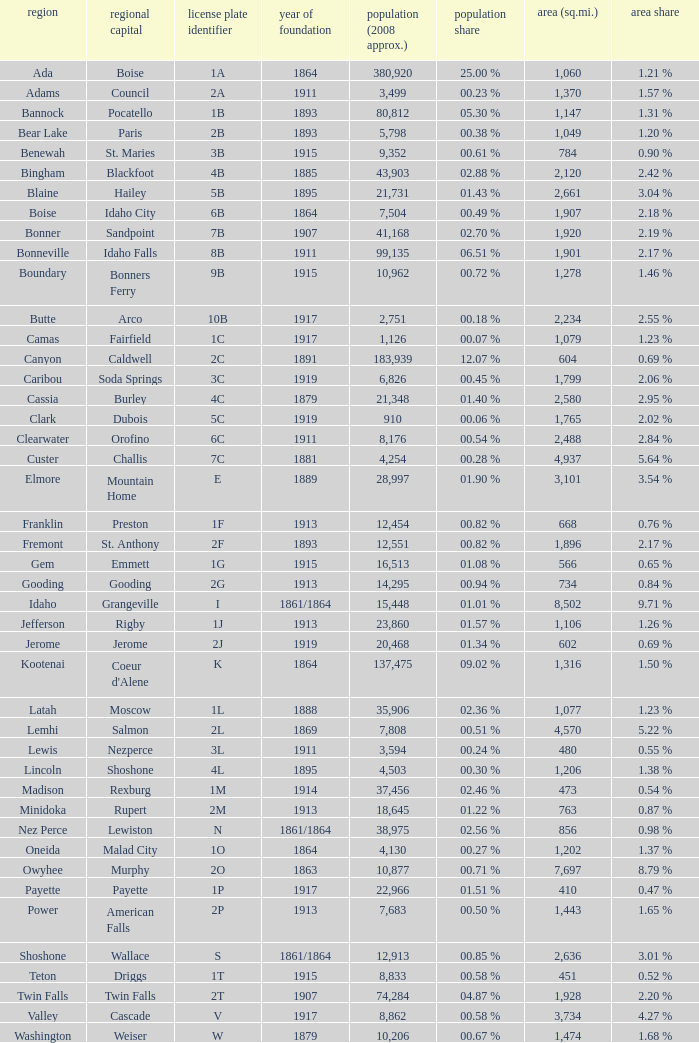What is the country seat for the license plate code 5c? Dubois. Would you mind parsing the complete table? {'header': ['region', 'regional capital', 'license plate identifier', 'year of foundation', 'population (2008 approx.)', 'population share', 'area (sq.mi.)', 'area share'], 'rows': [['Ada', 'Boise', '1A', '1864', '380,920', '25.00 %', '1,060', '1.21 %'], ['Adams', 'Council', '2A', '1911', '3,499', '00.23 %', '1,370', '1.57 %'], ['Bannock', 'Pocatello', '1B', '1893', '80,812', '05.30 %', '1,147', '1.31 %'], ['Bear Lake', 'Paris', '2B', '1893', '5,798', '00.38 %', '1,049', '1.20 %'], ['Benewah', 'St. Maries', '3B', '1915', '9,352', '00.61 %', '784', '0.90 %'], ['Bingham', 'Blackfoot', '4B', '1885', '43,903', '02.88 %', '2,120', '2.42 %'], ['Blaine', 'Hailey', '5B', '1895', '21,731', '01.43 %', '2,661', '3.04 %'], ['Boise', 'Idaho City', '6B', '1864', '7,504', '00.49 %', '1,907', '2.18 %'], ['Bonner', 'Sandpoint', '7B', '1907', '41,168', '02.70 %', '1,920', '2.19 %'], ['Bonneville', 'Idaho Falls', '8B', '1911', '99,135', '06.51 %', '1,901', '2.17 %'], ['Boundary', 'Bonners Ferry', '9B', '1915', '10,962', '00.72 %', '1,278', '1.46 %'], ['Butte', 'Arco', '10B', '1917', '2,751', '00.18 %', '2,234', '2.55 %'], ['Camas', 'Fairfield', '1C', '1917', '1,126', '00.07 %', '1,079', '1.23 %'], ['Canyon', 'Caldwell', '2C', '1891', '183,939', '12.07 %', '604', '0.69 %'], ['Caribou', 'Soda Springs', '3C', '1919', '6,826', '00.45 %', '1,799', '2.06 %'], ['Cassia', 'Burley', '4C', '1879', '21,348', '01.40 %', '2,580', '2.95 %'], ['Clark', 'Dubois', '5C', '1919', '910', '00.06 %', '1,765', '2.02 %'], ['Clearwater', 'Orofino', '6C', '1911', '8,176', '00.54 %', '2,488', '2.84 %'], ['Custer', 'Challis', '7C', '1881', '4,254', '00.28 %', '4,937', '5.64 %'], ['Elmore', 'Mountain Home', 'E', '1889', '28,997', '01.90 %', '3,101', '3.54 %'], ['Franklin', 'Preston', '1F', '1913', '12,454', '00.82 %', '668', '0.76 %'], ['Fremont', 'St. Anthony', '2F', '1893', '12,551', '00.82 %', '1,896', '2.17 %'], ['Gem', 'Emmett', '1G', '1915', '16,513', '01.08 %', '566', '0.65 %'], ['Gooding', 'Gooding', '2G', '1913', '14,295', '00.94 %', '734', '0.84 %'], ['Idaho', 'Grangeville', 'I', '1861/1864', '15,448', '01.01 %', '8,502', '9.71 %'], ['Jefferson', 'Rigby', '1J', '1913', '23,860', '01.57 %', '1,106', '1.26 %'], ['Jerome', 'Jerome', '2J', '1919', '20,468', '01.34 %', '602', '0.69 %'], ['Kootenai', "Coeur d'Alene", 'K', '1864', '137,475', '09.02 %', '1,316', '1.50 %'], ['Latah', 'Moscow', '1L', '1888', '35,906', '02.36 %', '1,077', '1.23 %'], ['Lemhi', 'Salmon', '2L', '1869', '7,808', '00.51 %', '4,570', '5.22 %'], ['Lewis', 'Nezperce', '3L', '1911', '3,594', '00.24 %', '480', '0.55 %'], ['Lincoln', 'Shoshone', '4L', '1895', '4,503', '00.30 %', '1,206', '1.38 %'], ['Madison', 'Rexburg', '1M', '1914', '37,456', '02.46 %', '473', '0.54 %'], ['Minidoka', 'Rupert', '2M', '1913', '18,645', '01.22 %', '763', '0.87 %'], ['Nez Perce', 'Lewiston', 'N', '1861/1864', '38,975', '02.56 %', '856', '0.98 %'], ['Oneida', 'Malad City', '1O', '1864', '4,130', '00.27 %', '1,202', '1.37 %'], ['Owyhee', 'Murphy', '2O', '1863', '10,877', '00.71 %', '7,697', '8.79 %'], ['Payette', 'Payette', '1P', '1917', '22,966', '01.51 %', '410', '0.47 %'], ['Power', 'American Falls', '2P', '1913', '7,683', '00.50 %', '1,443', '1.65 %'], ['Shoshone', 'Wallace', 'S', '1861/1864', '12,913', '00.85 %', '2,636', '3.01 %'], ['Teton', 'Driggs', '1T', '1915', '8,833', '00.58 %', '451', '0.52 %'], ['Twin Falls', 'Twin Falls', '2T', '1907', '74,284', '04.87 %', '1,928', '2.20 %'], ['Valley', 'Cascade', 'V', '1917', '8,862', '00.58 %', '3,734', '4.27 %'], ['Washington', 'Weiser', 'W', '1879', '10,206', '00.67 %', '1,474', '1.68 %']]} 